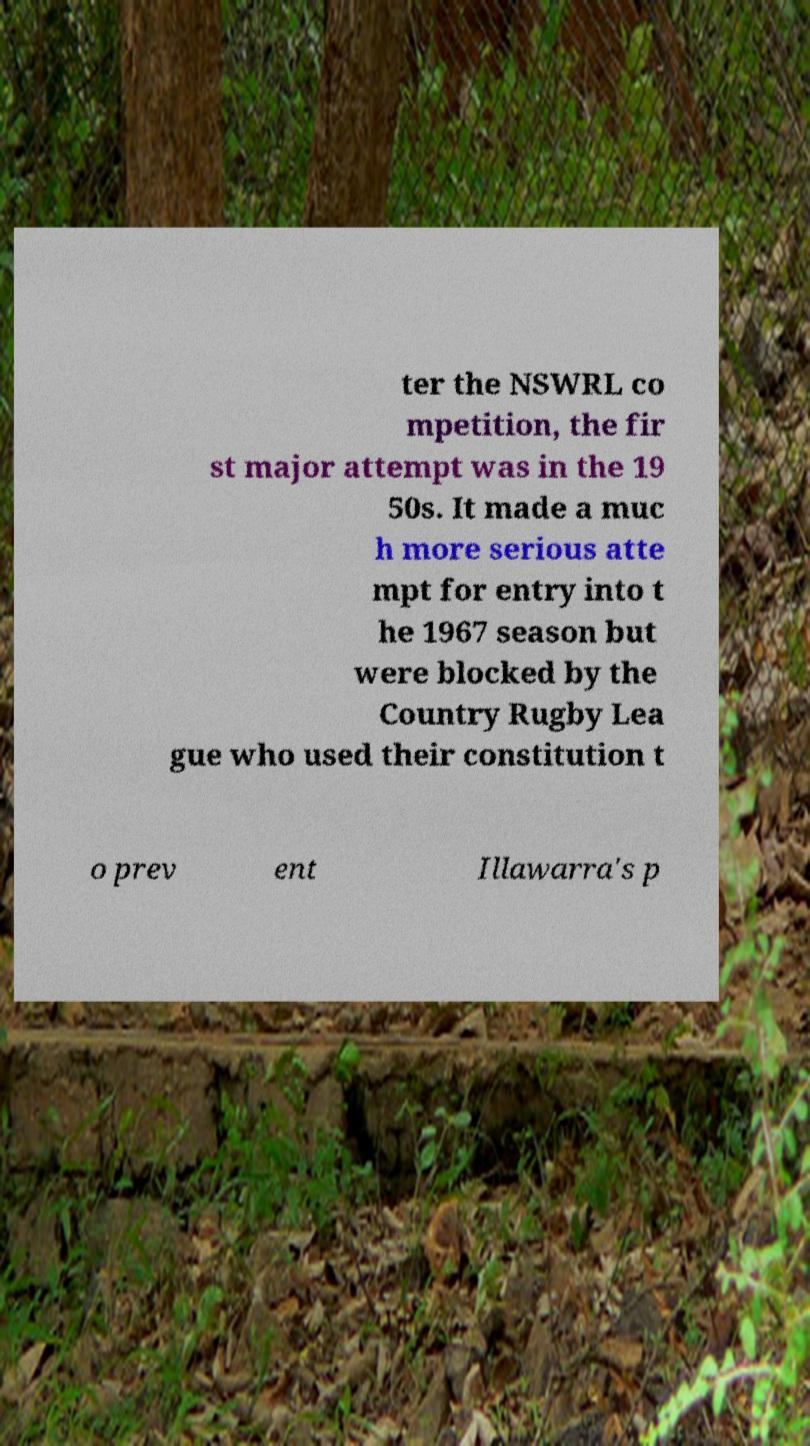Could you assist in decoding the text presented in this image and type it out clearly? ter the NSWRL co mpetition, the fir st major attempt was in the 19 50s. It made a muc h more serious atte mpt for entry into t he 1967 season but were blocked by the Country Rugby Lea gue who used their constitution t o prev ent Illawarra's p 